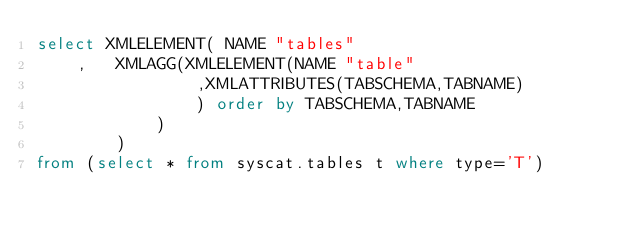<code> <loc_0><loc_0><loc_500><loc_500><_SQL_>select XMLELEMENT( NAME "tables"
	,	XMLAGG(XMLELEMENT(NAME "table"
				,XMLATTRIBUTES(TABSCHEMA,TABNAME)
				) order by TABSCHEMA,TABNAME
			)
		)
from (select * from syscat.tables t where type='T')</code> 